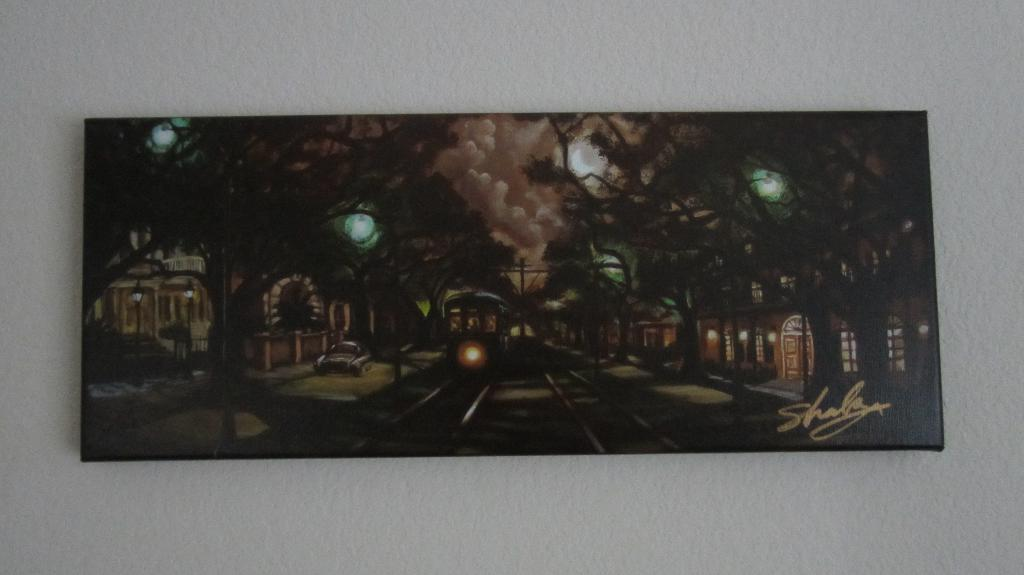<image>
Write a terse but informative summary of the picture. A long horizontal painting that was made by "Shala". 